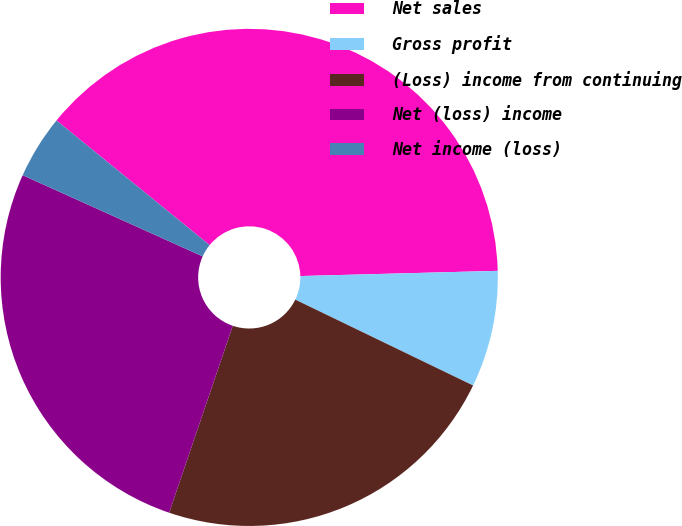Convert chart. <chart><loc_0><loc_0><loc_500><loc_500><pie_chart><fcel>Net sales<fcel>Gross profit<fcel>(Loss) income from continuing<fcel>Net (loss) income<fcel>Net income (loss)<nl><fcel>38.7%<fcel>7.58%<fcel>23.06%<fcel>26.52%<fcel>4.13%<nl></chart> 